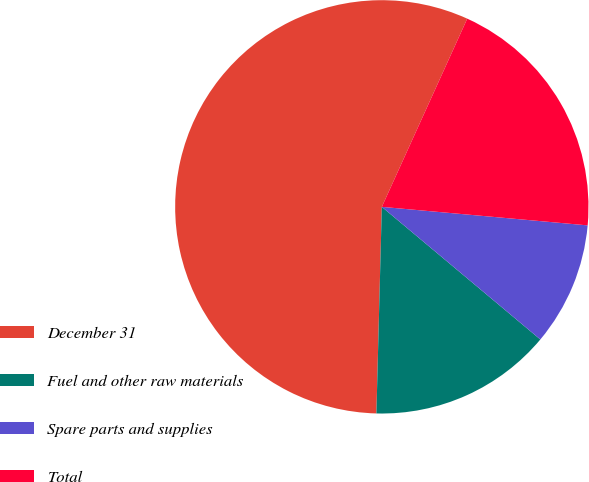<chart> <loc_0><loc_0><loc_500><loc_500><pie_chart><fcel>December 31<fcel>Fuel and other raw materials<fcel>Spare parts and supplies<fcel>Total<nl><fcel>56.37%<fcel>14.33%<fcel>9.66%<fcel>19.65%<nl></chart> 